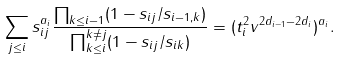<formula> <loc_0><loc_0><loc_500><loc_500>\sum _ { j \leq i } s _ { i j } ^ { a _ { i } } \frac { \prod _ { k \leq i - 1 } ( 1 - s _ { i j } / s _ { i - 1 , k } ) } { \prod _ { k \leq i } ^ { k \ne j } ( 1 - s _ { i j } / s _ { i k } ) } = ( t _ { i } ^ { 2 } v ^ { 2 d _ { i - 1 } - 2 d _ { i } } ) ^ { a _ { i } } .</formula> 